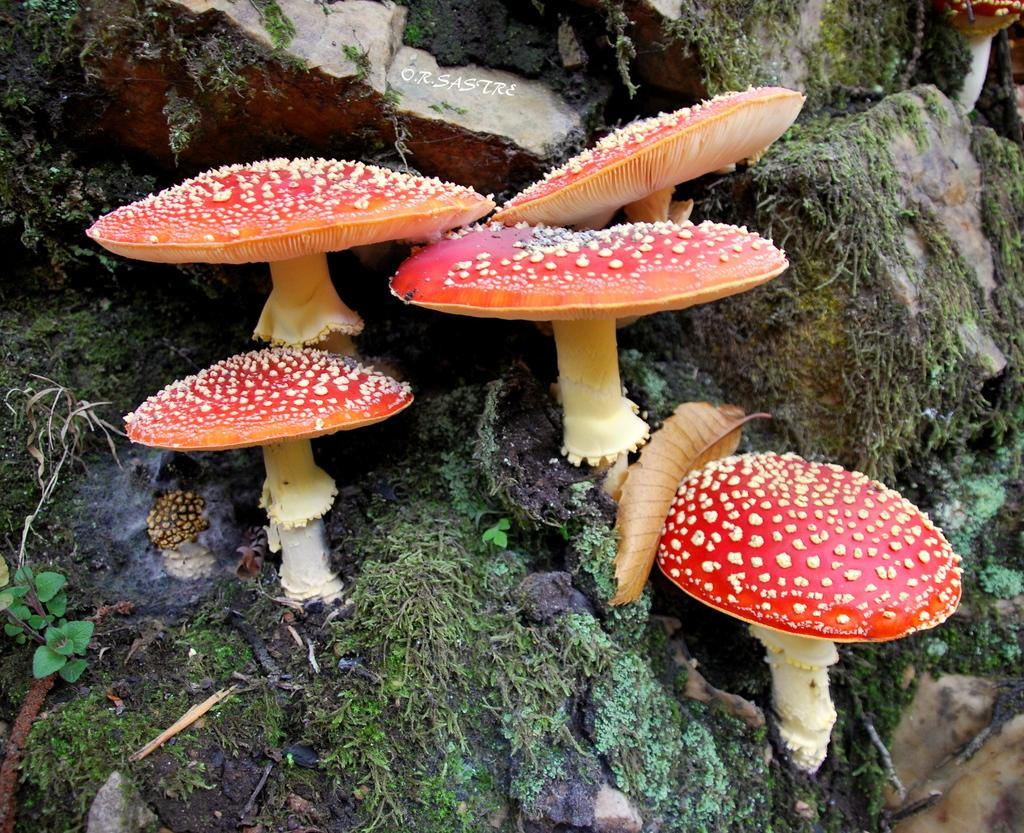What is located in the center of the image? There are mushrooms in the center of the image. What can be found at the bottom of the image? There are rocks at the bottom of the image. What type of game is being played in the image? There is no game being played in the image; it features mushrooms and rocks. Can you describe the fang of the creature in the image? There is no creature with a fang present in the image; it only contains mushrooms and rocks. 